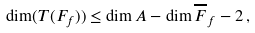<formula> <loc_0><loc_0><loc_500><loc_500>\dim ( T ( F _ { f } ) ) \leq \dim A - \dim \overline { F } _ { f } - 2 \, ,</formula> 